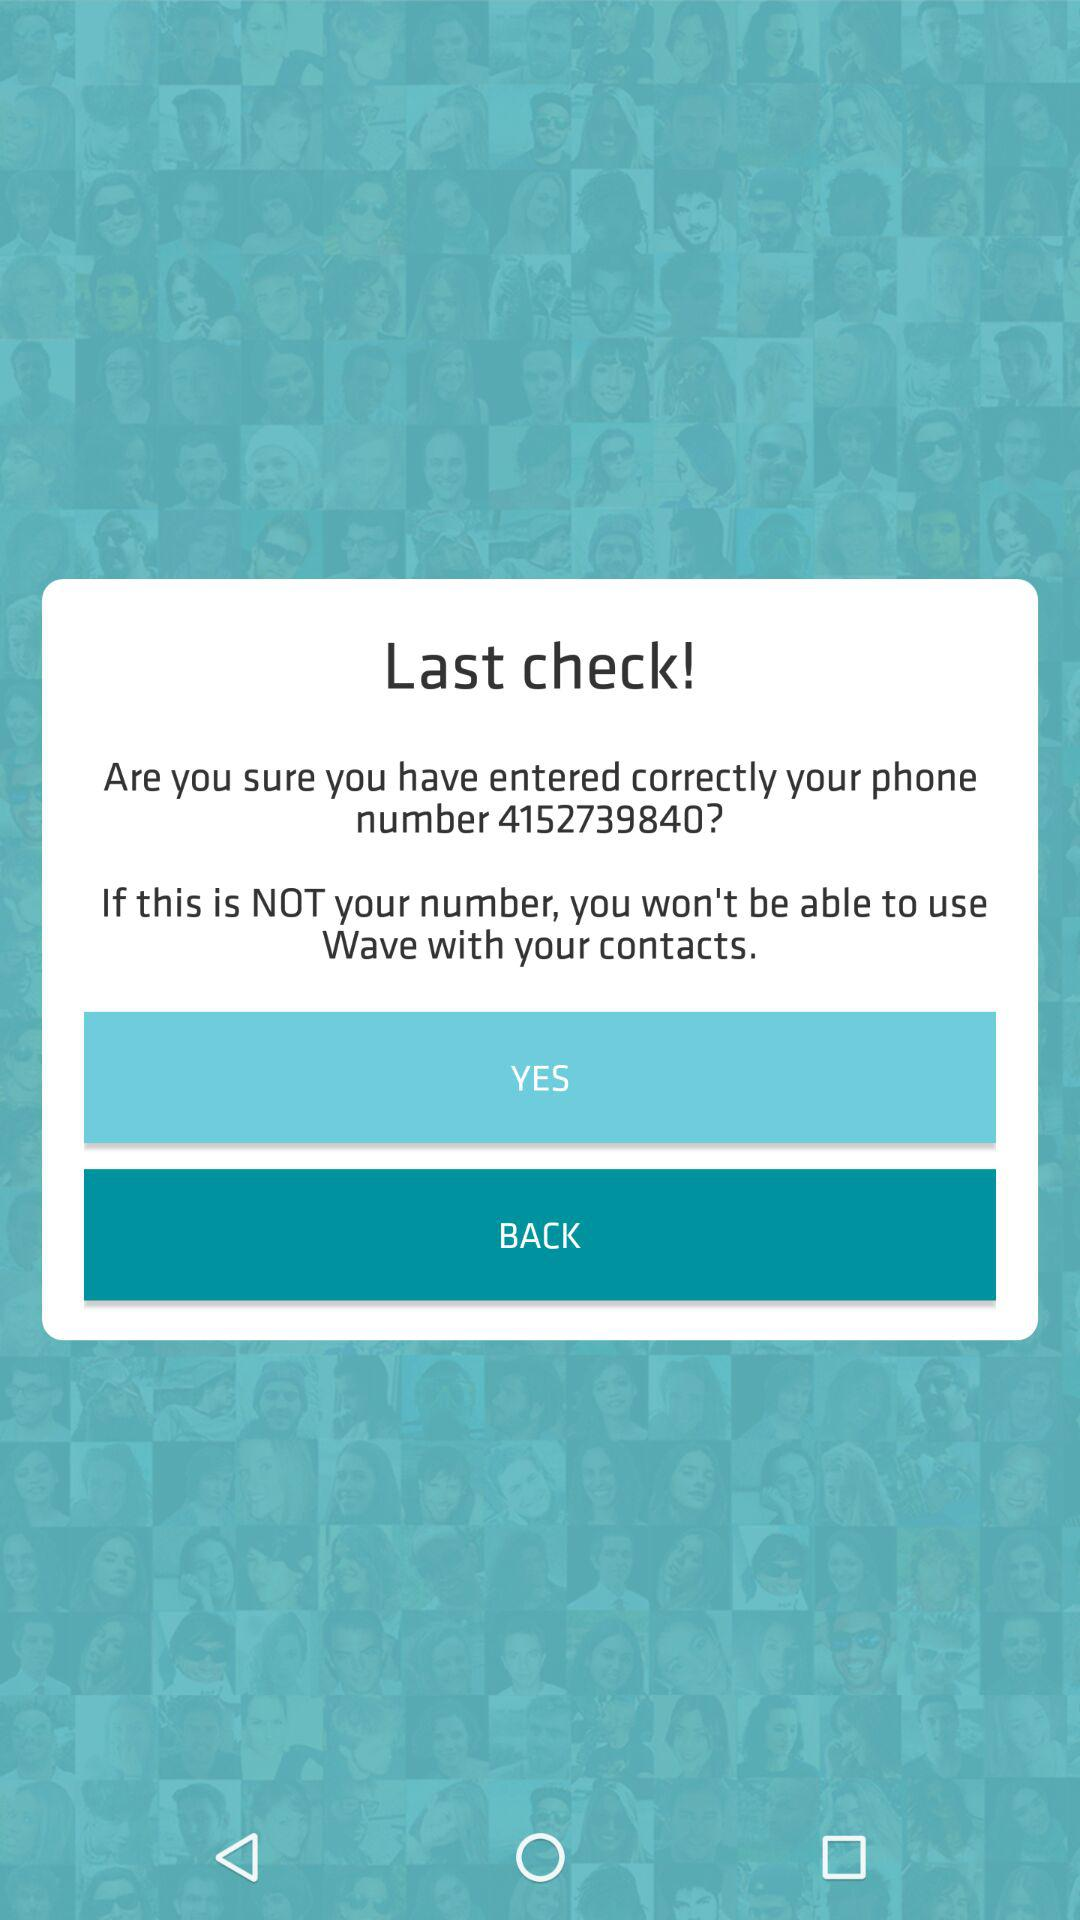What is the phone number entered by the user? The phone number is 4152739840. 